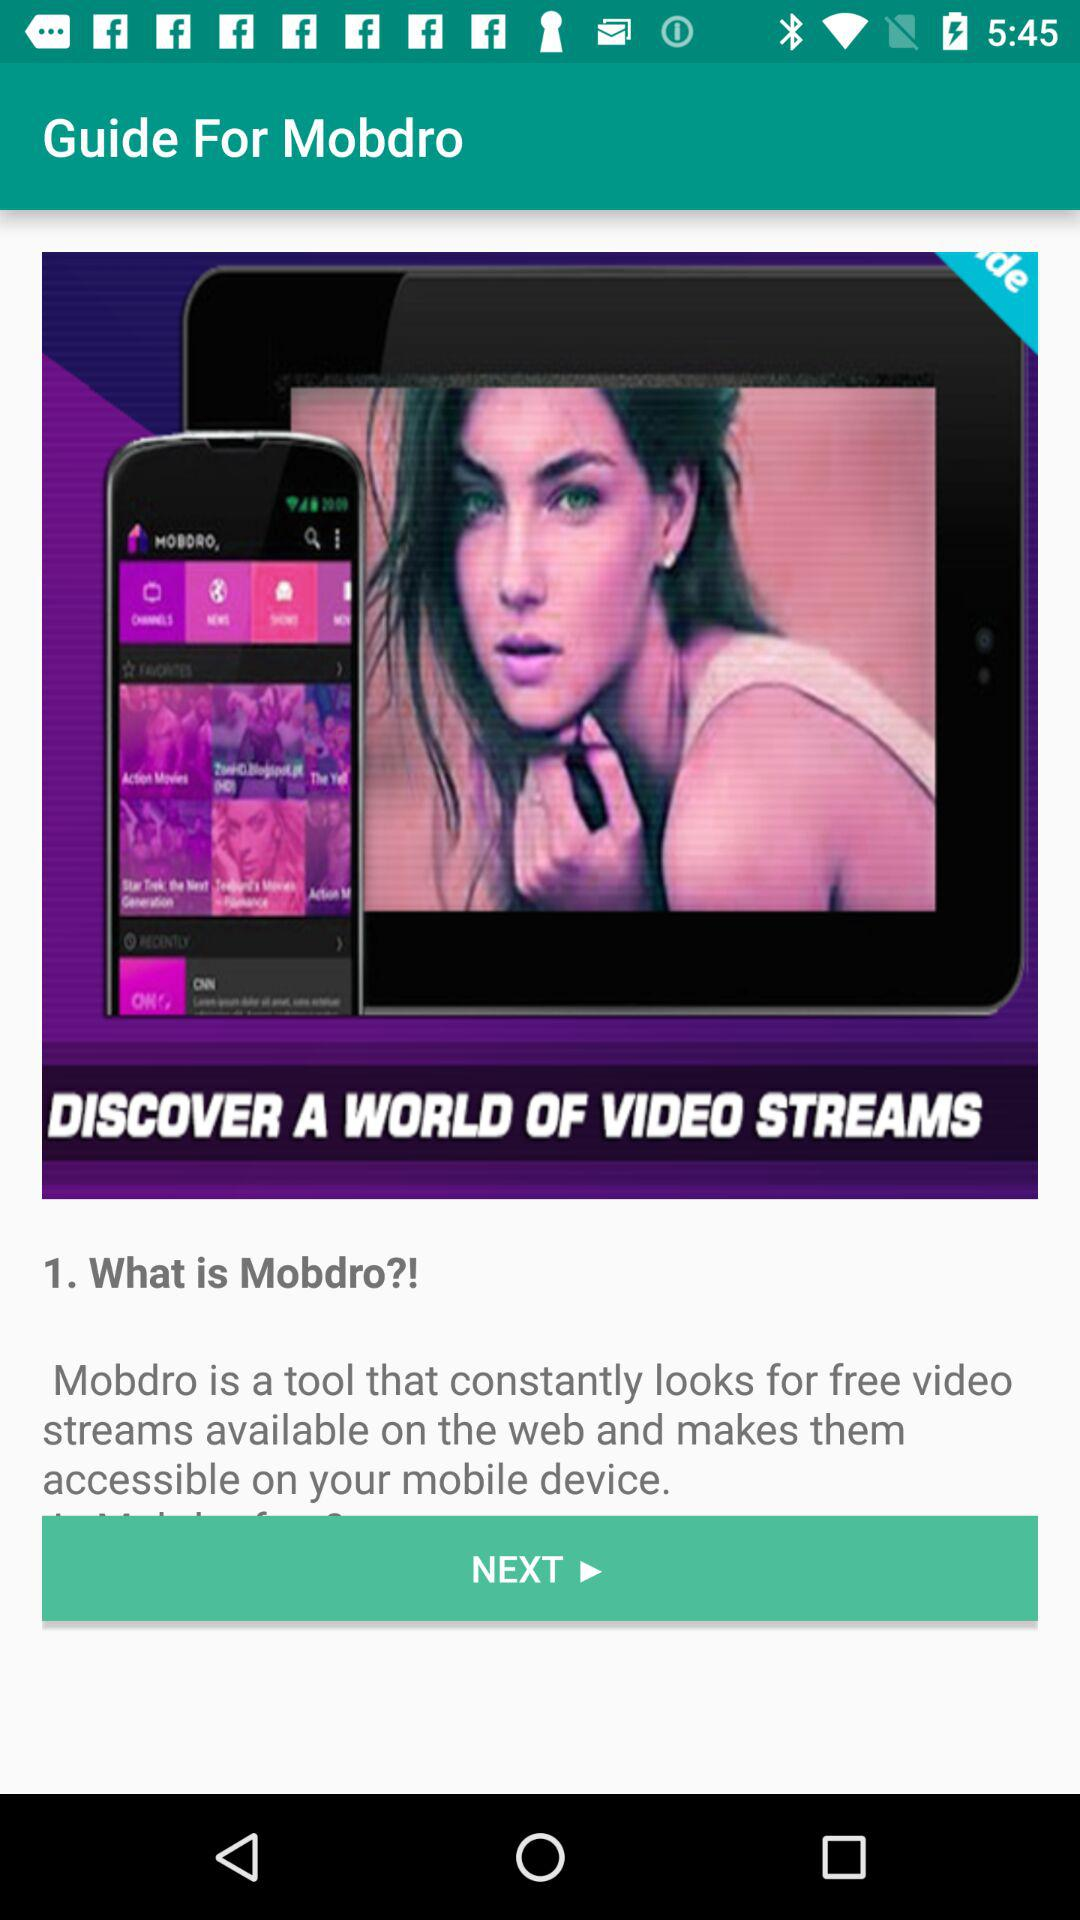What is the application name? The application name is "Guide For Mobdro". 